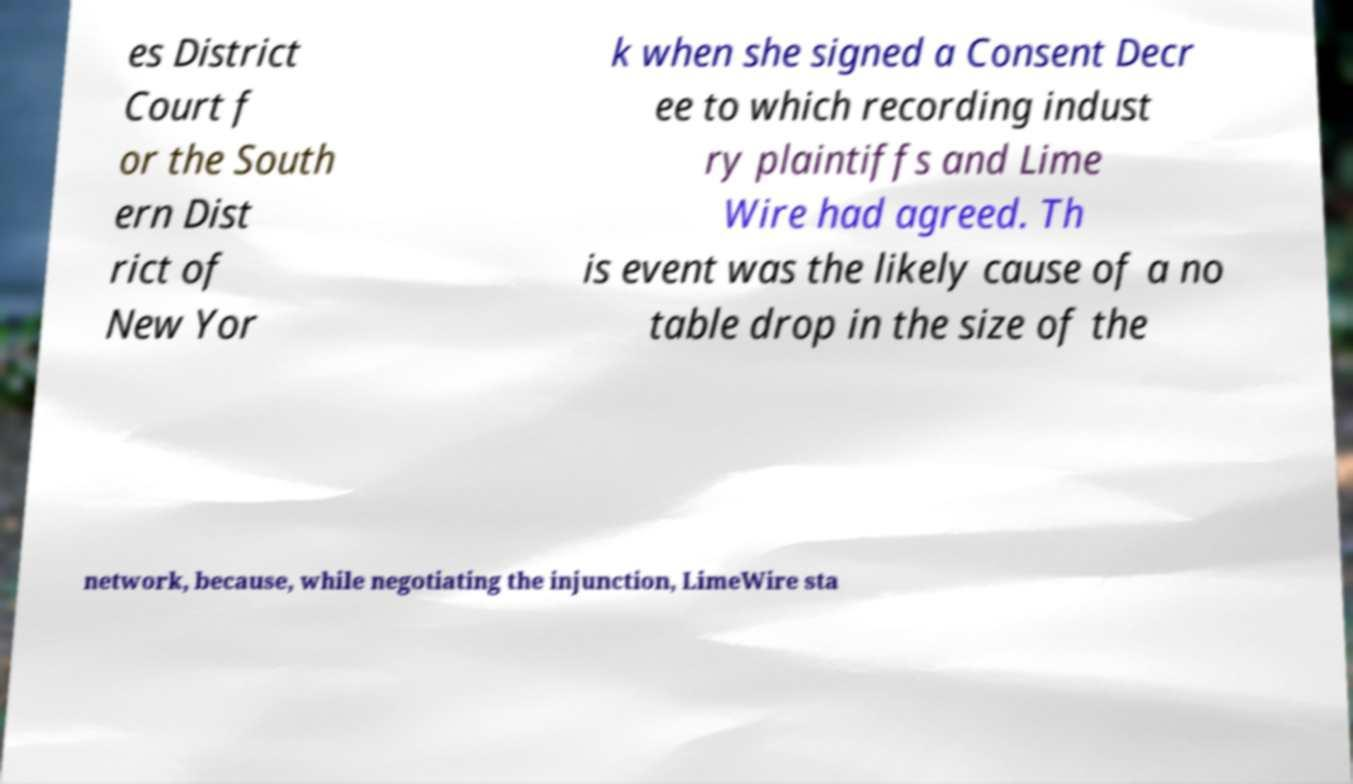For documentation purposes, I need the text within this image transcribed. Could you provide that? es District Court f or the South ern Dist rict of New Yor k when she signed a Consent Decr ee to which recording indust ry plaintiffs and Lime Wire had agreed. Th is event was the likely cause of a no table drop in the size of the network, because, while negotiating the injunction, LimeWire sta 